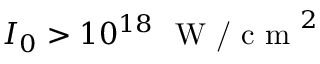Convert formula to latex. <formula><loc_0><loc_0><loc_500><loc_500>I _ { 0 } > 1 0 ^ { 1 8 } \ W / c m ^ { 2 }</formula> 